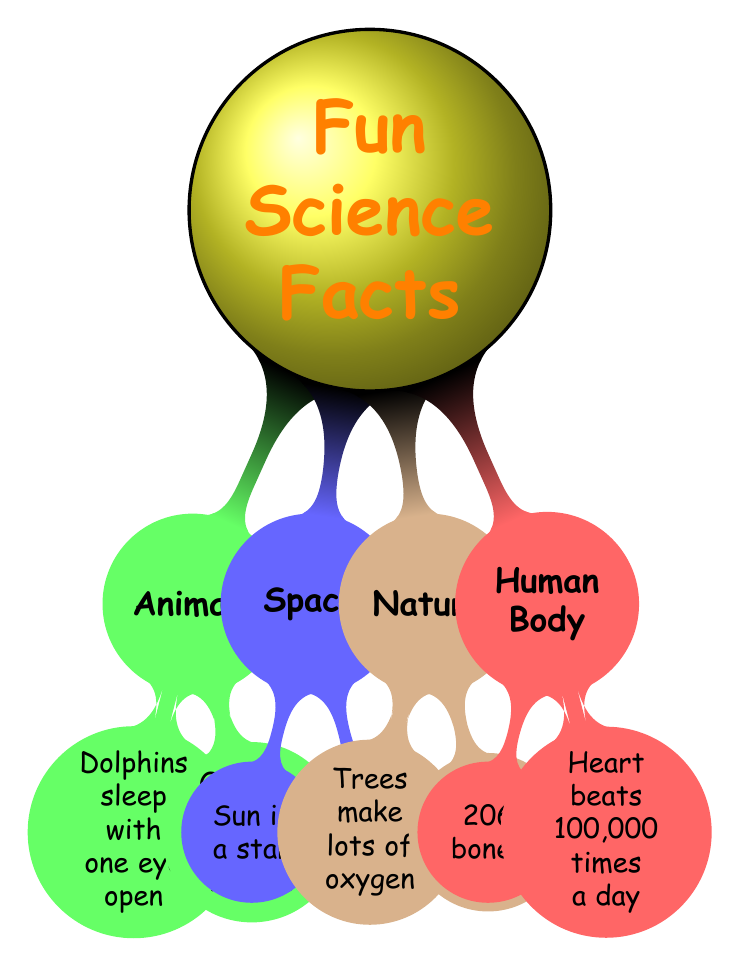What animal sleeps with one eye open? The "Animals" section lists "Dolphins" which is accompanied by the fact that they "sleep with one eye open." Thus, the answer comes directly from that node.
Answer: Dolphins How many hearts does an octopus have? In the "Animals" section, under "Octopus," it states that "An octopus has three hearts." Therefore, the concise answer reflects this information.
Answer: Three What is produced by a single tree each year? In the "Nature" section, it indicates that "A single tree can produce around 260 pounds of oxygen each year." So, the answer is found in that node.
Answer: Oxygen How many bones do humans have? The "Human Body" section mentions "Humans have 206 bones." This direct statement provides the answer to the question.
Answer: 206 What color is the heart in the diagram? The heart is located in the "Human Body" section, portrayed in red within the mind map. The question asks for the color representing the heart.
Answer: Red What is the relation between the Sun and the stars? The "Space" section states "Sun is a star." To answer this question, we need to recognize that the diagram connects the concept of the Sun directly to the category of stars.
Answer: Star What beats 100,000 times a day? Within the "Human Body" section, the node states "Your heart beats about 100,000 times a day." This clear statement gives a direct answer.
Answer: Heart Which section of the diagram has rocks that can float? In the "Nature" section, it mentions "Some rocks can float on water." Therefore, the answer identifies which part of the diagram contains this fact.
Answer: Nature 